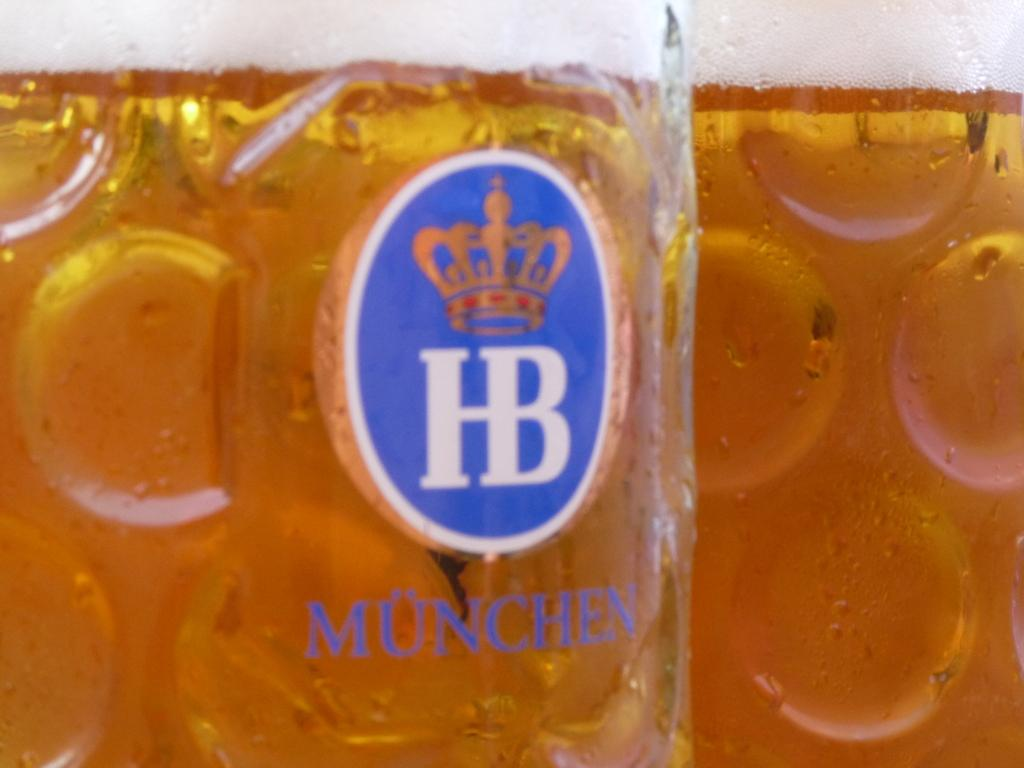<image>
Describe the image concisely. Cup of Munchen beer with a blue logo and a crown. 